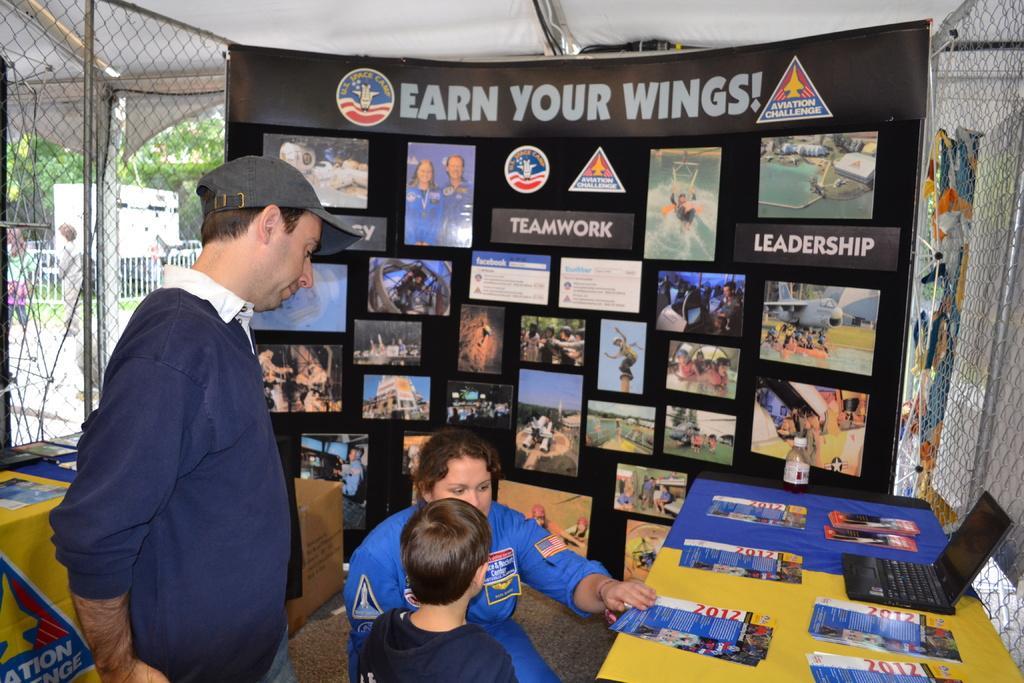Can you describe this image briefly? In the center of the image, we can see people and there are some papers and a laptop are placed on the table. In the background, we can see a mesh and a banner. 